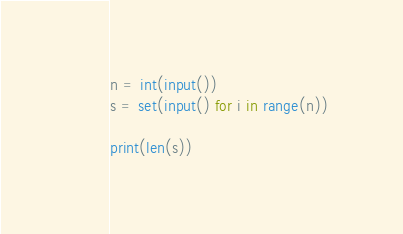<code> <loc_0><loc_0><loc_500><loc_500><_Python_>n = int(input())
s = set(input() for i in range(n))

print(len(s))

</code> 